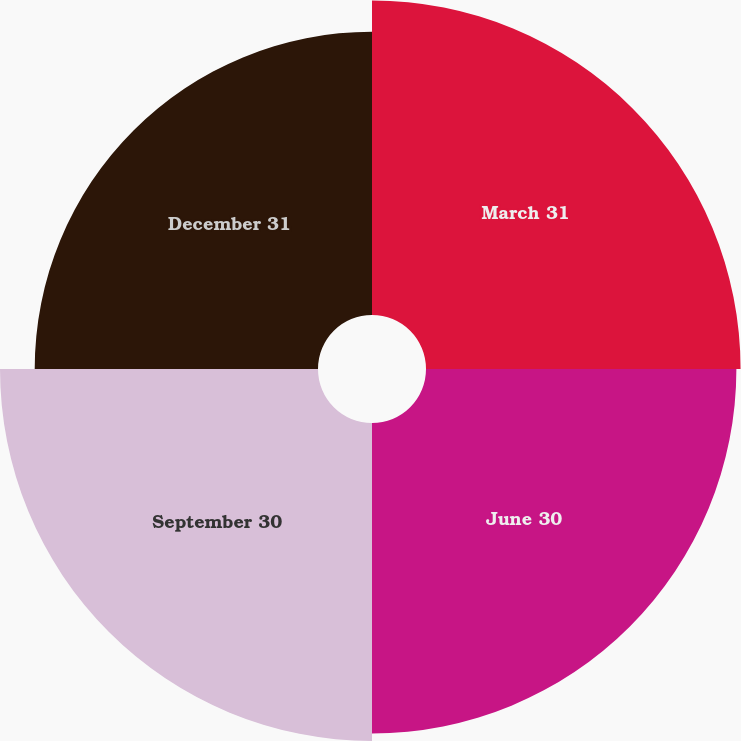Convert chart to OTSL. <chart><loc_0><loc_0><loc_500><loc_500><pie_chart><fcel>March 31<fcel>June 30<fcel>September 30<fcel>December 31<nl><fcel>25.65%<fcel>25.31%<fcel>25.93%<fcel>23.1%<nl></chart> 